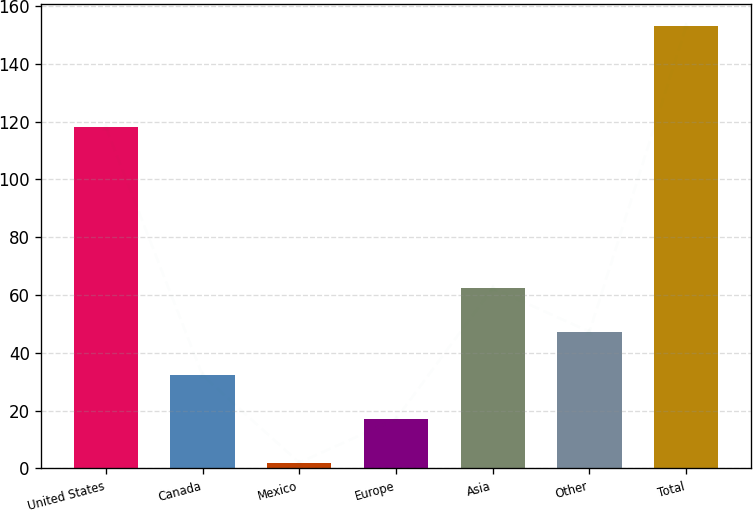<chart> <loc_0><loc_0><loc_500><loc_500><bar_chart><fcel>United States<fcel>Canada<fcel>Mexico<fcel>Europe<fcel>Asia<fcel>Other<fcel>Total<nl><fcel>118<fcel>32.2<fcel>2<fcel>17.1<fcel>62.4<fcel>47.3<fcel>153<nl></chart> 